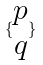Convert formula to latex. <formula><loc_0><loc_0><loc_500><loc_500>\{ \begin{matrix} p \\ q \end{matrix} \}</formula> 